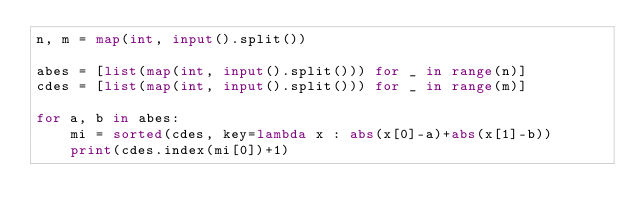Convert code to text. <code><loc_0><loc_0><loc_500><loc_500><_Python_>n, m = map(int, input().split())

abes = [list(map(int, input().split())) for _ in range(n)]
cdes = [list(map(int, input().split())) for _ in range(m)]

for a, b in abes:
    mi = sorted(cdes, key=lambda x : abs(x[0]-a)+abs(x[1]-b))
    print(cdes.index(mi[0])+1)</code> 